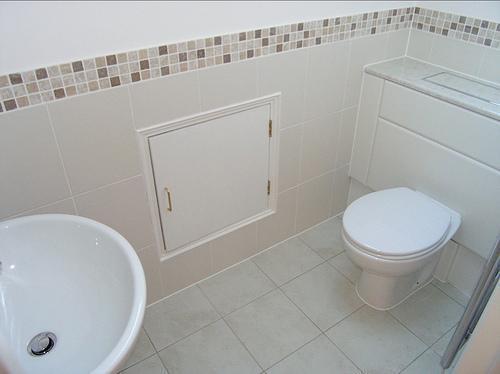How many cars are on the road?
Give a very brief answer. 0. 